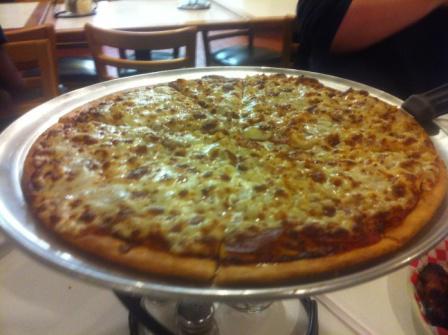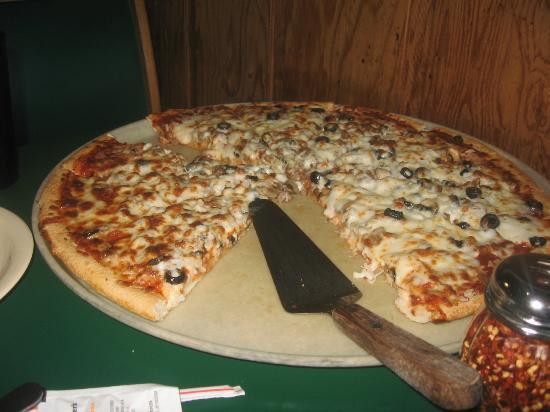The first image is the image on the left, the second image is the image on the right. Examine the images to the left and right. Is the description "One of the pizzas is placed next to some fresh uncut tomatoes." accurate? Answer yes or no. No. The first image is the image on the left, the second image is the image on the right. Considering the images on both sides, is "There is one whole pizza in the right image." valid? Answer yes or no. No. 